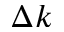<formula> <loc_0><loc_0><loc_500><loc_500>\Delta k</formula> 